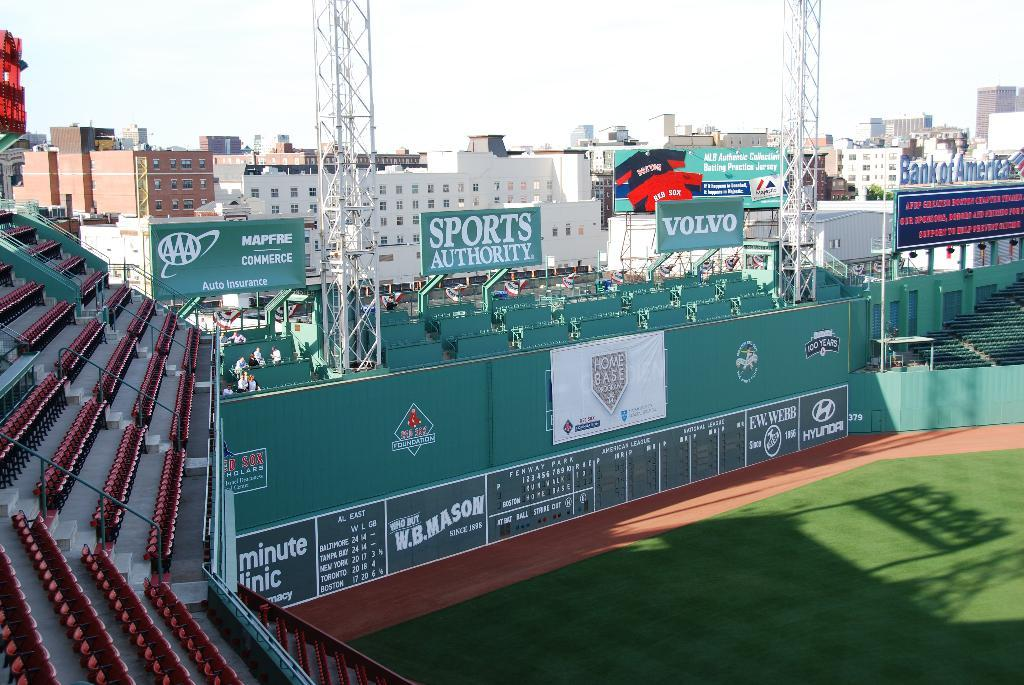What type of structures can be seen in the image? There are many buildings in the image. What type of sports facility is present in the image? There is a football ground in the image. What type of advertisements or promotional materials can be seen in the image? There are hoardings in the image. What is the condition of the sky in the image? The sky is clear and visible at the top of the image. Can you tell me what type of apparel your father is wearing in the image? There is no person, including a father, present in the image. How fast is the person running in the image? There is no person running in the image. 